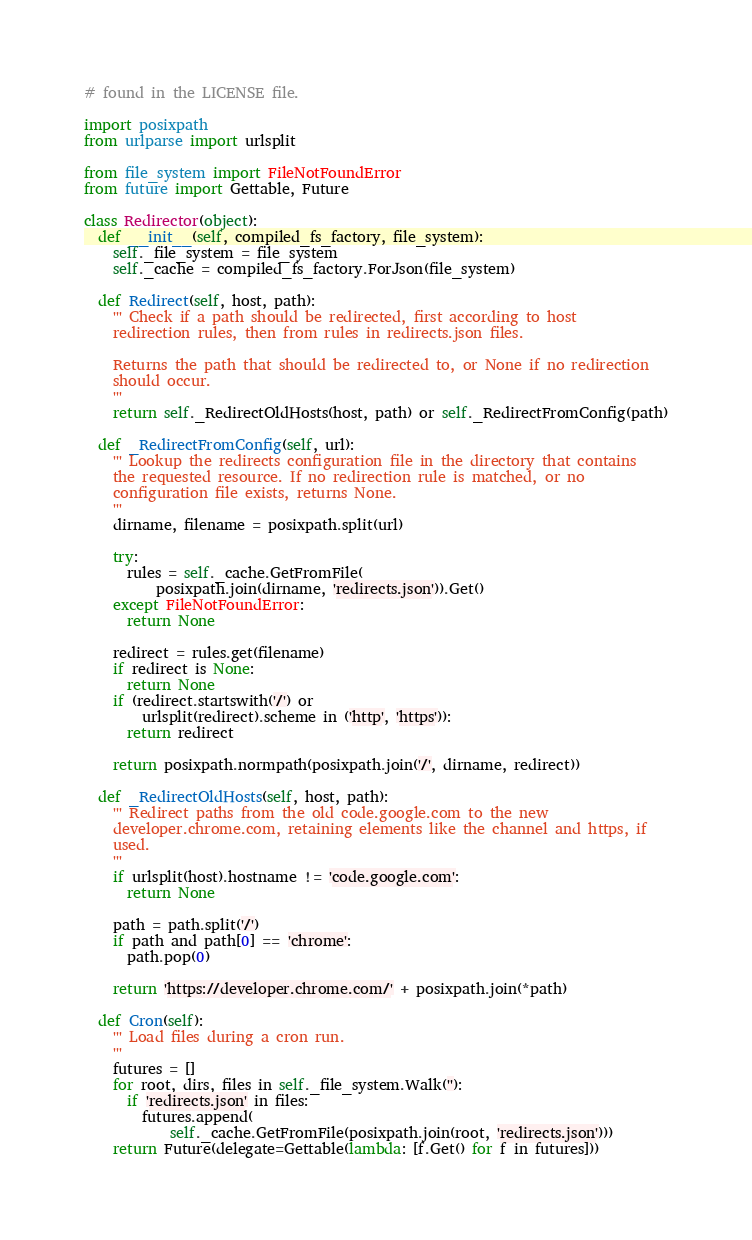<code> <loc_0><loc_0><loc_500><loc_500><_Python_># found in the LICENSE file.

import posixpath
from urlparse import urlsplit

from file_system import FileNotFoundError
from future import Gettable, Future

class Redirector(object):
  def __init__(self, compiled_fs_factory, file_system):
    self._file_system = file_system
    self._cache = compiled_fs_factory.ForJson(file_system)

  def Redirect(self, host, path):
    ''' Check if a path should be redirected, first according to host
    redirection rules, then from rules in redirects.json files.

    Returns the path that should be redirected to, or None if no redirection
    should occur.
    '''
    return self._RedirectOldHosts(host, path) or self._RedirectFromConfig(path)

  def _RedirectFromConfig(self, url):
    ''' Lookup the redirects configuration file in the directory that contains
    the requested resource. If no redirection rule is matched, or no
    configuration file exists, returns None.
    '''
    dirname, filename = posixpath.split(url)

    try:
      rules = self._cache.GetFromFile(
          posixpath.join(dirname, 'redirects.json')).Get()
    except FileNotFoundError:
      return None

    redirect = rules.get(filename)
    if redirect is None:
      return None
    if (redirect.startswith('/') or
        urlsplit(redirect).scheme in ('http', 'https')):
      return redirect

    return posixpath.normpath(posixpath.join('/', dirname, redirect))

  def _RedirectOldHosts(self, host, path):
    ''' Redirect paths from the old code.google.com to the new
    developer.chrome.com, retaining elements like the channel and https, if
    used.
    '''
    if urlsplit(host).hostname != 'code.google.com':
      return None

    path = path.split('/')
    if path and path[0] == 'chrome':
      path.pop(0)

    return 'https://developer.chrome.com/' + posixpath.join(*path)

  def Cron(self):
    ''' Load files during a cron run.
    '''
    futures = []
    for root, dirs, files in self._file_system.Walk(''):
      if 'redirects.json' in files:
        futures.append(
            self._cache.GetFromFile(posixpath.join(root, 'redirects.json')))
    return Future(delegate=Gettable(lambda: [f.Get() for f in futures]))
</code> 